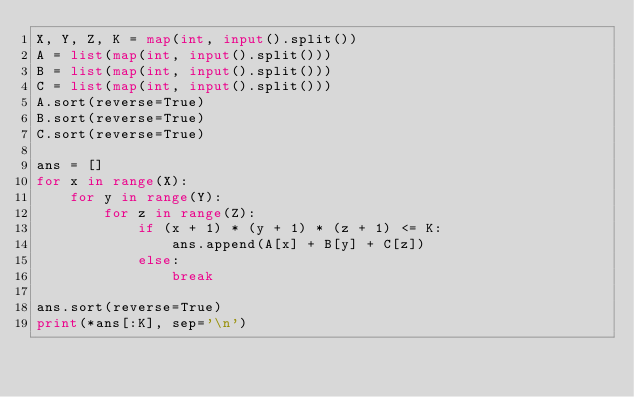Convert code to text. <code><loc_0><loc_0><loc_500><loc_500><_Python_>X, Y, Z, K = map(int, input().split())
A = list(map(int, input().split()))
B = list(map(int, input().split()))
C = list(map(int, input().split()))
A.sort(reverse=True)
B.sort(reverse=True)
C.sort(reverse=True)

ans = []
for x in range(X):
    for y in range(Y):
        for z in range(Z):
            if (x + 1) * (y + 1) * (z + 1) <= K:
                ans.append(A[x] + B[y] + C[z])
            else:
                break

ans.sort(reverse=True)
print(*ans[:K], sep='\n')
</code> 